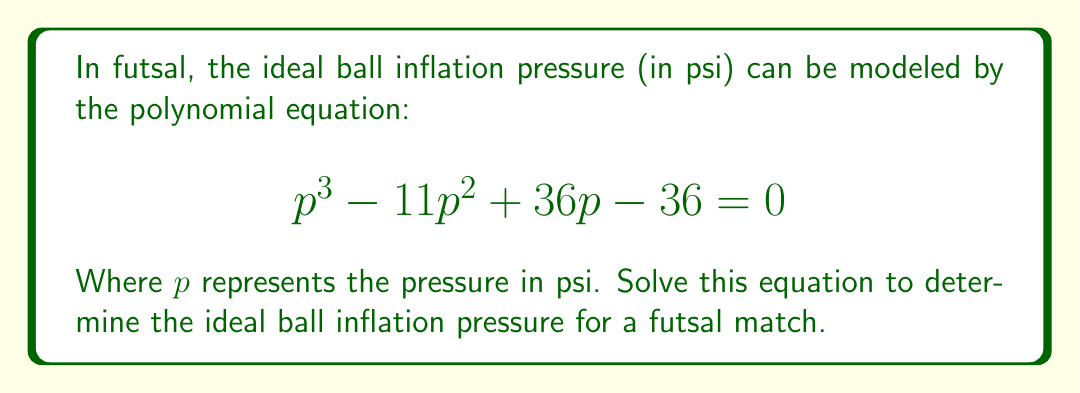Can you solve this math problem? Let's solve this step-by-step using factoring methods:

1) First, we can try to factor out any common terms. In this case, there are no common factors.

2) Next, we can try to use the rational root theorem. The possible rational roots are the factors of the constant term (36): ±1, ±2, ±3, ±4, ±6, ±9, ±12, ±18, ±36

3) By testing these values, we find that p = 3 is a root of the equation.

4) We can factor out (p - 3):

   $$p^3 - 11p^2 + 36p - 36 = (p - 3)(p^2 - 8p + 12)$$

5) The quadratic factor $p^2 - 8p + 12$ can be further factored:

   $$p^3 - 11p^2 + 36p - 36 = (p - 3)(p - 6)(p - 2)$$

6) Setting each factor to zero:

   $p - 3 = 0$, $p - 6 = 0$, $p - 2 = 0$

7) Solving these linear equations:

   $p = 3$, $p = 6$, $p = 2$

8) Among these solutions, 6 psi is too high for a futsal ball, and 2 psi is too low. The ideal pressure for a futsal ball is typically around 6-8 lbs (0.6-0.8 bar), which is equivalent to about 3-4 psi.

Therefore, the ideal ball inflation pressure for futsal is 3 psi.
Answer: 3 psi 